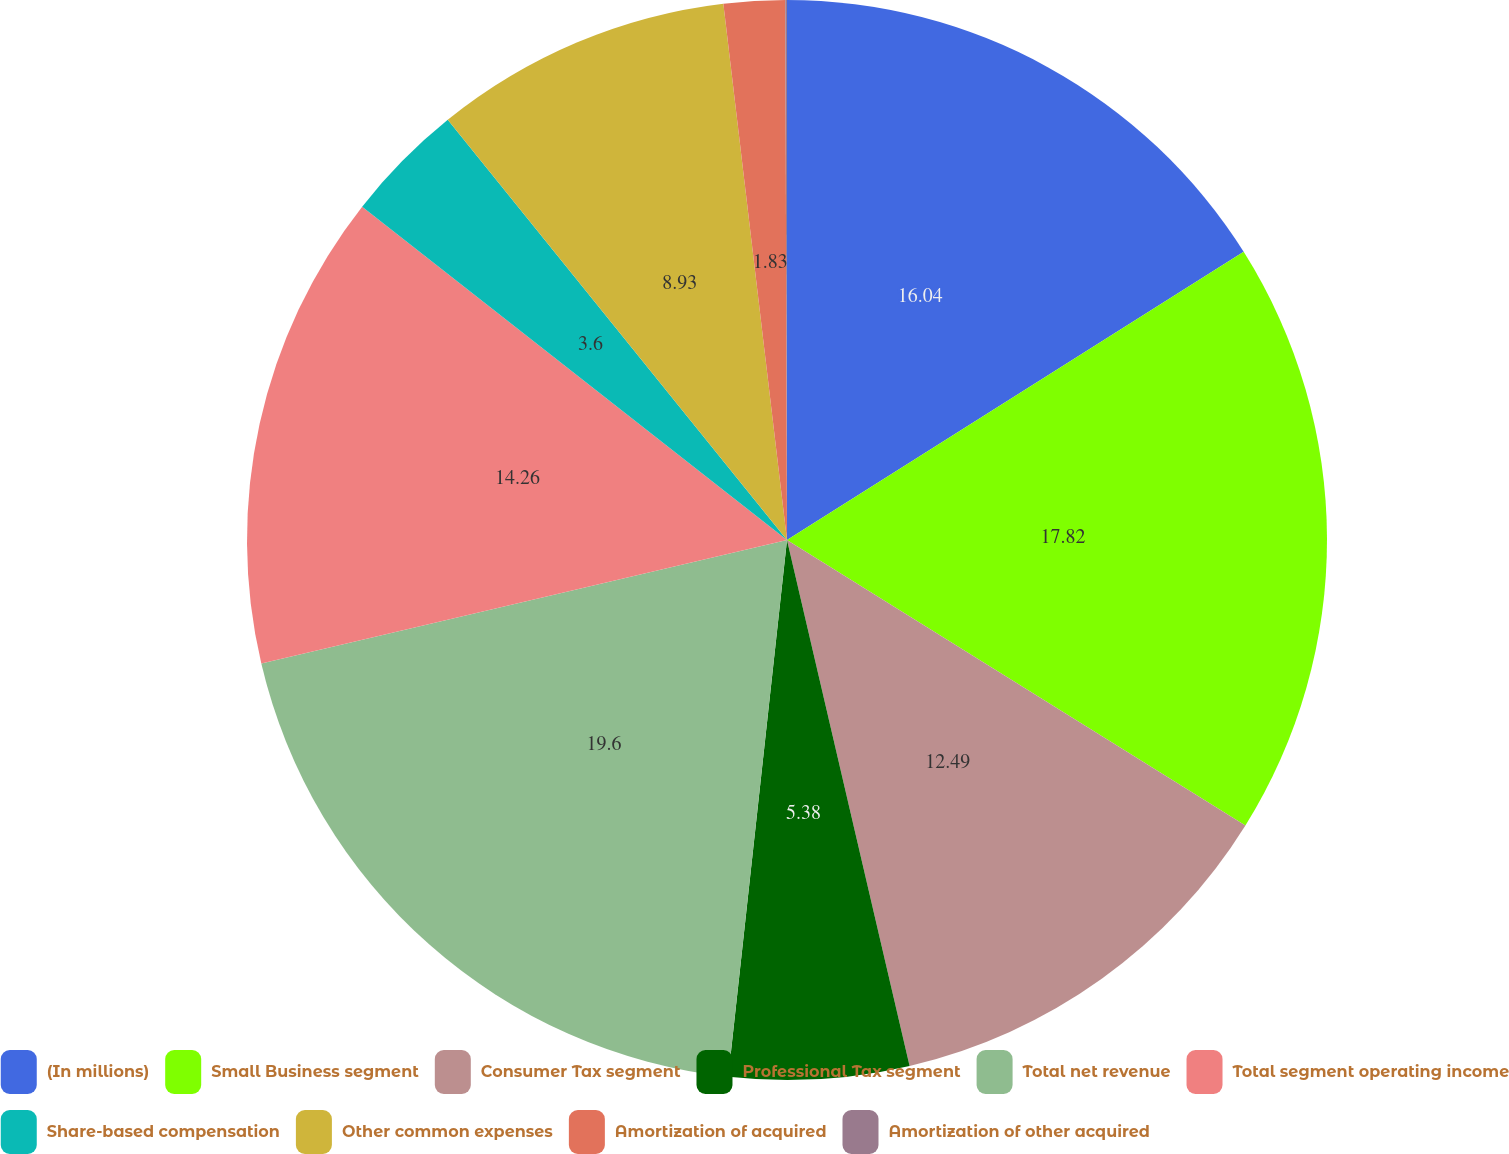Convert chart. <chart><loc_0><loc_0><loc_500><loc_500><pie_chart><fcel>(In millions)<fcel>Small Business segment<fcel>Consumer Tax segment<fcel>Professional Tax segment<fcel>Total net revenue<fcel>Total segment operating income<fcel>Share-based compensation<fcel>Other common expenses<fcel>Amortization of acquired<fcel>Amortization of other acquired<nl><fcel>16.04%<fcel>17.82%<fcel>12.49%<fcel>5.38%<fcel>19.59%<fcel>14.26%<fcel>3.6%<fcel>8.93%<fcel>1.83%<fcel>0.05%<nl></chart> 